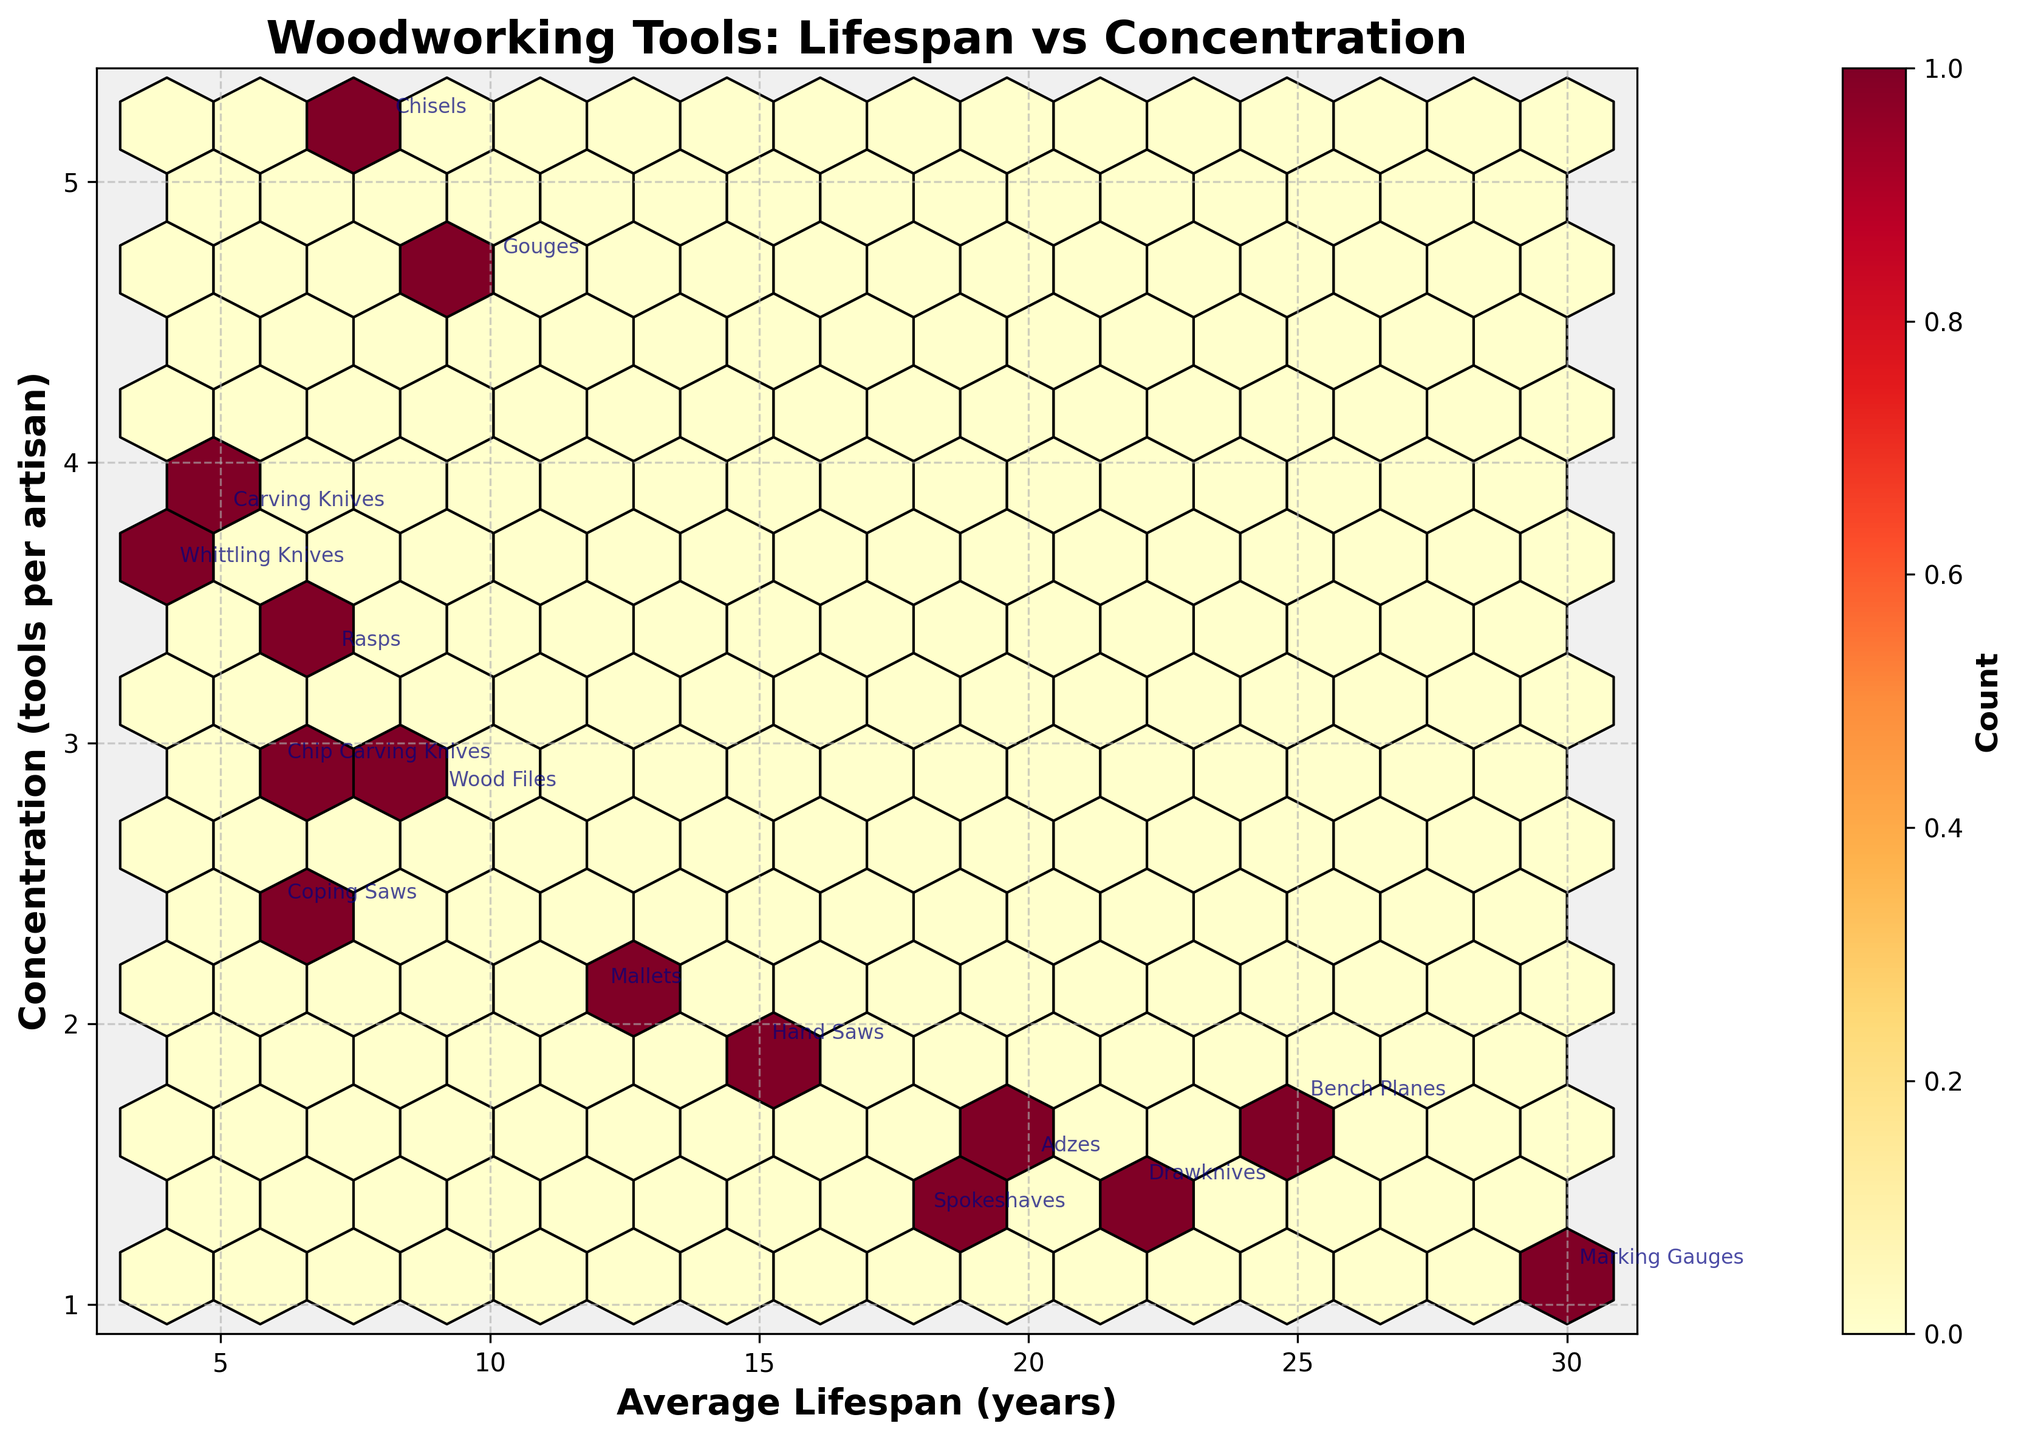What's the title of the figure? The title is located at the top of the figure and usually provides a summary of what the plot shows. By reading the title, "Woodworking Tools: Lifespan vs Concentration", you can understand that the plot depicts the relationship between the average lifespan of woodworking tools and their concentration per artisan.
Answer: Woodworking Tools: Lifespan vs Concentration What do the x and y axes represent? The axes labels provide this information. The x-axis represents the average lifespan of the tools in years, and the y-axis represents the concentration of tools per artisan.
Answer: x-axis: Average Lifespan (years), y-axis: Concentration (tools per artisan) What tool has the highest concentration per artisan? By looking at the annotated data points, the tool type "Chisels" has the highest concentration at 5.2 tools per artisan.
Answer: Chisels Which tool has the longest average lifespan and what is its concentration? By observing the annotated points, "Marking Gauges" has the longest average lifespan of 30 years and a concentration of 1.1 tools per artisan.
Answer: Marking Gauges, 1.1 How many tools have an average lifespan of less than 10 years? Each label on the x-axis corresponds to the lifespan, and tools can be counted directly based on their annotated values. The tools are Chisels (8), Carving Knives (5), Coping Saws (6), Whittling Knives (4), Chip Carving Knives (6), and Rasps (7), totaling 6 tools.
Answer: 6 tools What is the average concentration of tools with a lifespan greater than 20 years? To find the average concentration, sum the concentrations and divide by the number of tools. Tools: Adzes (1.5), Bench Planes (1.7), Spokeshaves (1.3), Drawknives (1.4), Marking Gauges (1.1). Total concentration = 1.5 + 1.7 + 1.3 + 1.4 + 1.1 = 7. Top number of tools = 5, so the average is 7 / 5 = 1.4
Answer: 1.4 Which tool group has a lifespan closest to the average lifespan of the dataset? Calculate the average lifespan: Sum of lifespans = 8 + 5 + 12 + 10 + 15 + 7 + 20 + 6 + 4 + 25 + 18 + 9 + 30 + 22 + 6 = 197. Number of tools = 15, so the average lifespan = 197 / 15 ≈ 13.13 years. The tool group with a lifespan closest to this average is "Hand Saws" at 15 years.
Answer: Hand Saws Which tool type is both annotated and located in a highly dense bin (dark red hexagon)? The density of tools is indicated by the color of the hexagons. The darker the hexagon, the higher the density of data points. Observe that "Gouges" is within a dark hexagon and annotated with reasonable concentration and lifespan.
Answer: Gouges What is the concentration of tools with the shortest lifespan, and which tool is it? The tool "Whittling Knives" has the shortest average lifespan at 4 years and its concentration is 3.6 tools per artisan.
Answer: 3.6, Whittling Knives Among tools with a lifespan between 5 to 10 years, what is the most concentrated tool type? Lifespan range [5, 10] includes Carving Knives (3.8), Rasps (3.3), Chisels (5.2), Coping Saws (2.4), and Chip Carving Knives (2.9). The highest concentration among these is "Chisels" at 5.2 tools per artisan.
Answer: Chisels 